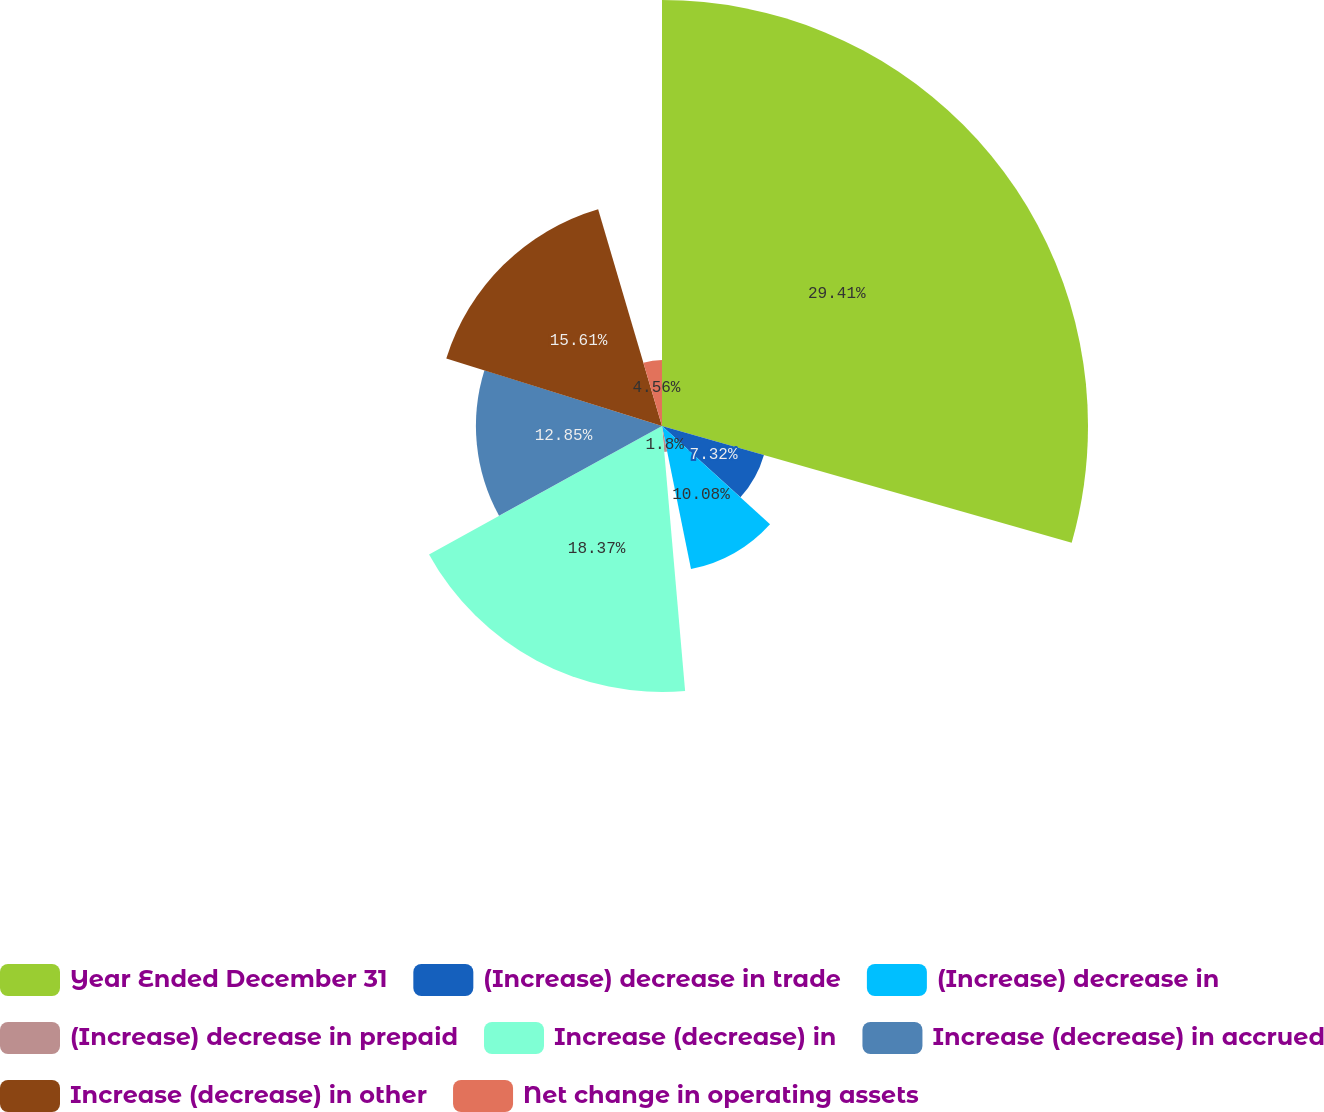Convert chart to OTSL. <chart><loc_0><loc_0><loc_500><loc_500><pie_chart><fcel>Year Ended December 31<fcel>(Increase) decrease in trade<fcel>(Increase) decrease in<fcel>(Increase) decrease in prepaid<fcel>Increase (decrease) in<fcel>Increase (decrease) in accrued<fcel>Increase (decrease) in other<fcel>Net change in operating assets<nl><fcel>29.42%<fcel>7.32%<fcel>10.08%<fcel>1.8%<fcel>18.37%<fcel>12.85%<fcel>15.61%<fcel>4.56%<nl></chart> 